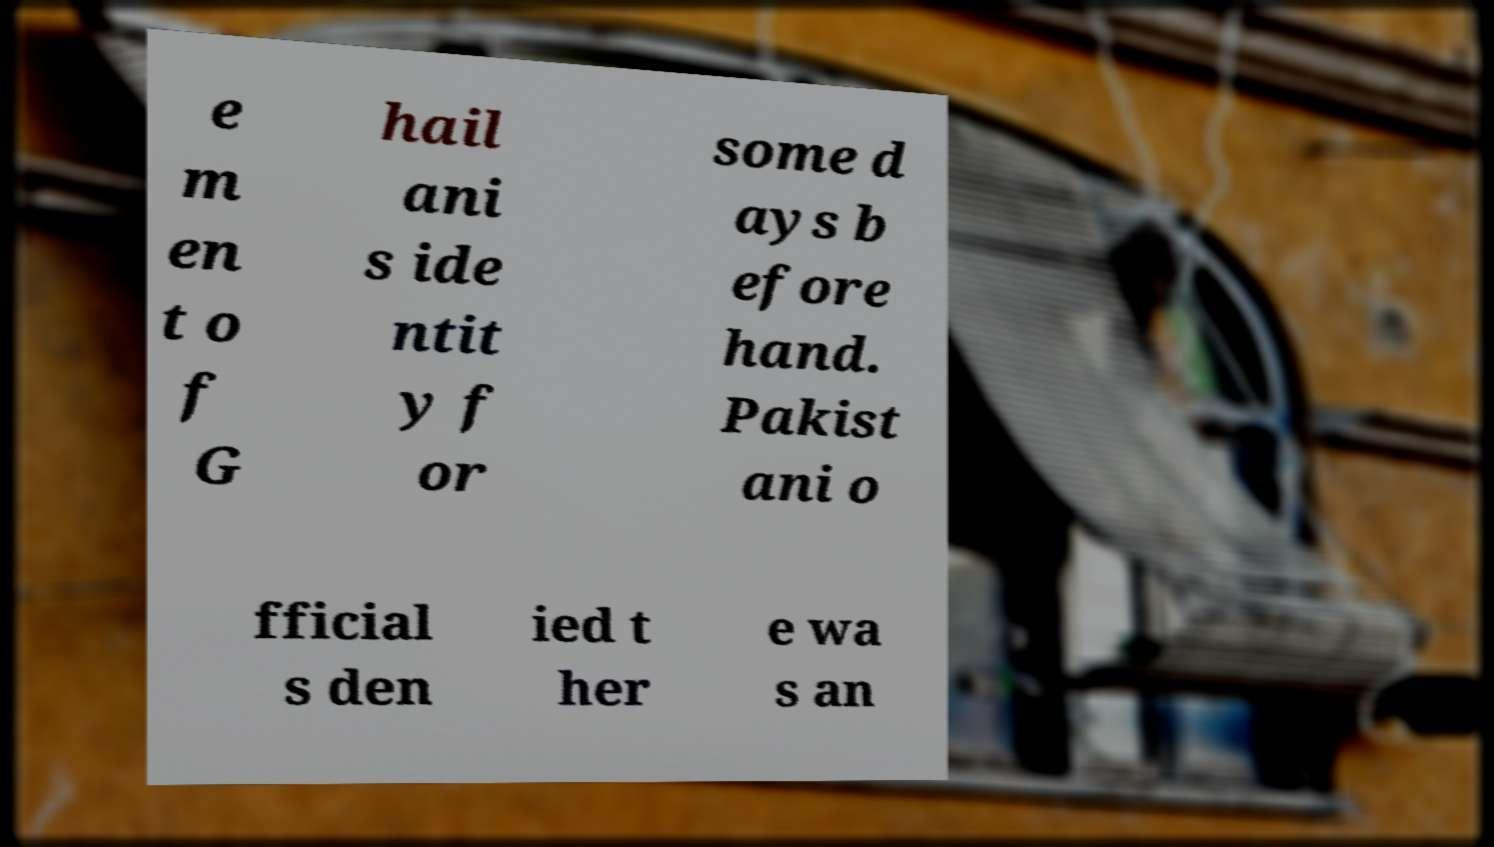For documentation purposes, I need the text within this image transcribed. Could you provide that? e m en t o f G hail ani s ide ntit y f or some d ays b efore hand. Pakist ani o fficial s den ied t her e wa s an 